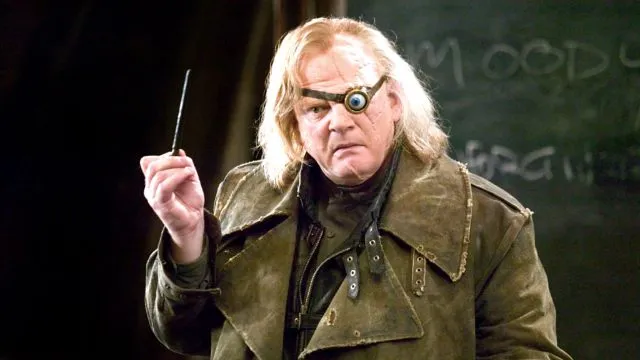What are the key elements in this picture? The image displays a man characterized by his striking, rugged attire and a distinctive magical eye, capturing a fantasy genre vibe. He is dressed in a worn dark green coat and holds a wand, which suggests he is portraying a wizard. The backdrop is dark, focusing our attention on him and his intense expression, which adds to the character's mystique. 